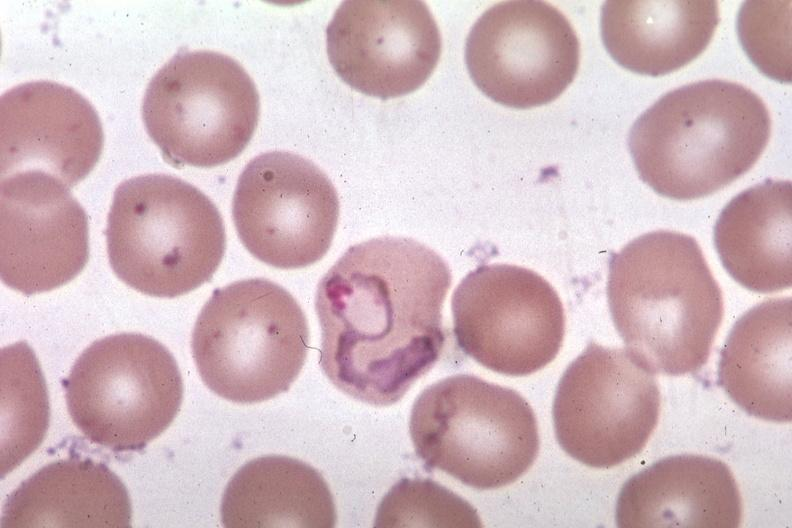s acute lymphocytic leukemia present?
Answer the question using a single word or phrase. No 